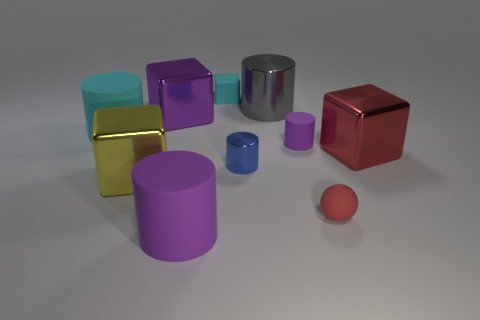There is a object that is the same color as the tiny ball; what shape is it?
Give a very brief answer. Cube. How many other objects are the same material as the small block?
Your answer should be compact. 4. Does the matte object that is behind the big purple metal object have the same size as the blue shiny thing that is in front of the big cyan object?
Provide a succinct answer. Yes. What number of objects are either objects right of the tiny red ball or big objects in front of the small shiny cylinder?
Your answer should be very brief. 3. Are there any other things that are the same shape as the tiny red matte object?
Your answer should be very brief. No. Do the matte cube that is on the right side of the large purple metallic thing and the rubber cylinder that is behind the small purple matte object have the same color?
Ensure brevity in your answer.  Yes. How many matte things are big yellow blocks or cylinders?
Your answer should be very brief. 3. The large rubber object in front of the big block in front of the blue thing is what shape?
Ensure brevity in your answer.  Cylinder. Is the cyan thing that is on the left side of the large purple cube made of the same material as the big block right of the small purple rubber cylinder?
Your response must be concise. No. What number of shiny cubes are behind the small cylinder behind the blue metallic cylinder?
Give a very brief answer. 1. 